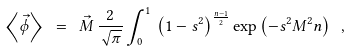<formula> <loc_0><loc_0><loc_500><loc_500>\left < \vec { \phi } \right > \ = \ \vec { M } \, \frac { 2 } { \sqrt { \pi } } \int _ { 0 } ^ { 1 } \, \left ( 1 - s ^ { 2 } \right ) ^ { \frac { n - 1 } { 2 } } \exp \left ( - s ^ { 2 } M ^ { 2 } n \right ) \ ,</formula> 